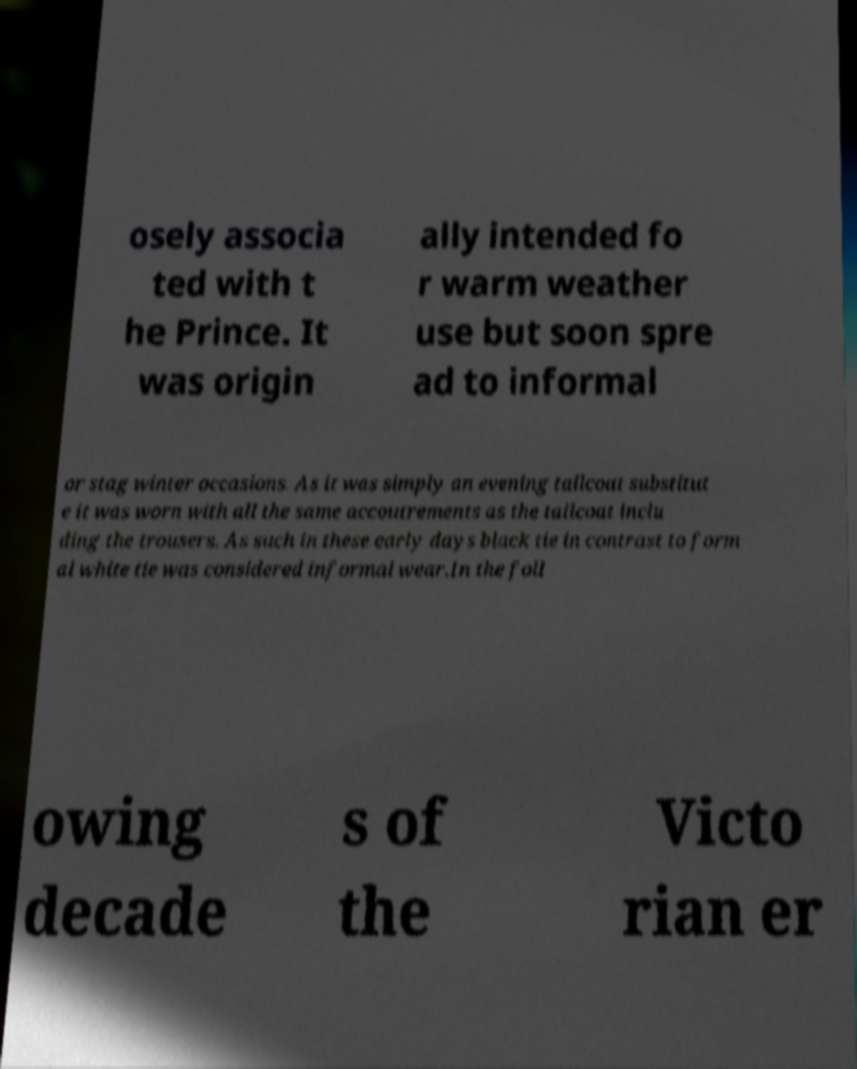Can you accurately transcribe the text from the provided image for me? osely associa ted with t he Prince. It was origin ally intended fo r warm weather use but soon spre ad to informal or stag winter occasions. As it was simply an evening tailcoat substitut e it was worn with all the same accoutrements as the tailcoat inclu ding the trousers. As such in these early days black tie in contrast to form al white tie was considered informal wear.In the foll owing decade s of the Victo rian er 